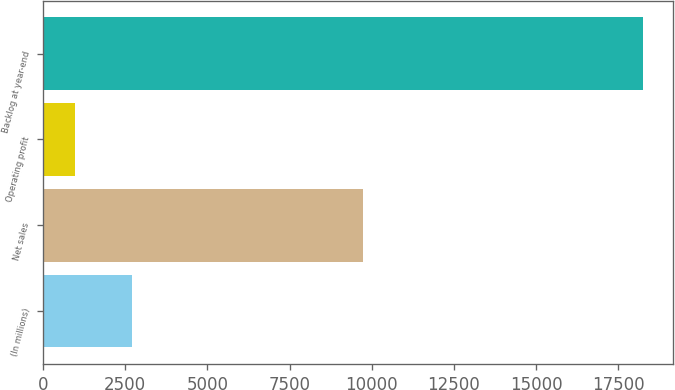Convert chart. <chart><loc_0><loc_0><loc_500><loc_500><bar_chart><fcel>(In millions)<fcel>Net sales<fcel>Operating profit<fcel>Backlog at year-end<nl><fcel>2696<fcel>9729<fcel>969<fcel>18239<nl></chart> 